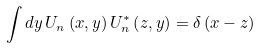Convert formula to latex. <formula><loc_0><loc_0><loc_500><loc_500>\int d y \, U _ { n } \left ( x , y \right ) U _ { n } ^ { * } \left ( z , y \right ) = \delta \left ( x - z \right )</formula> 